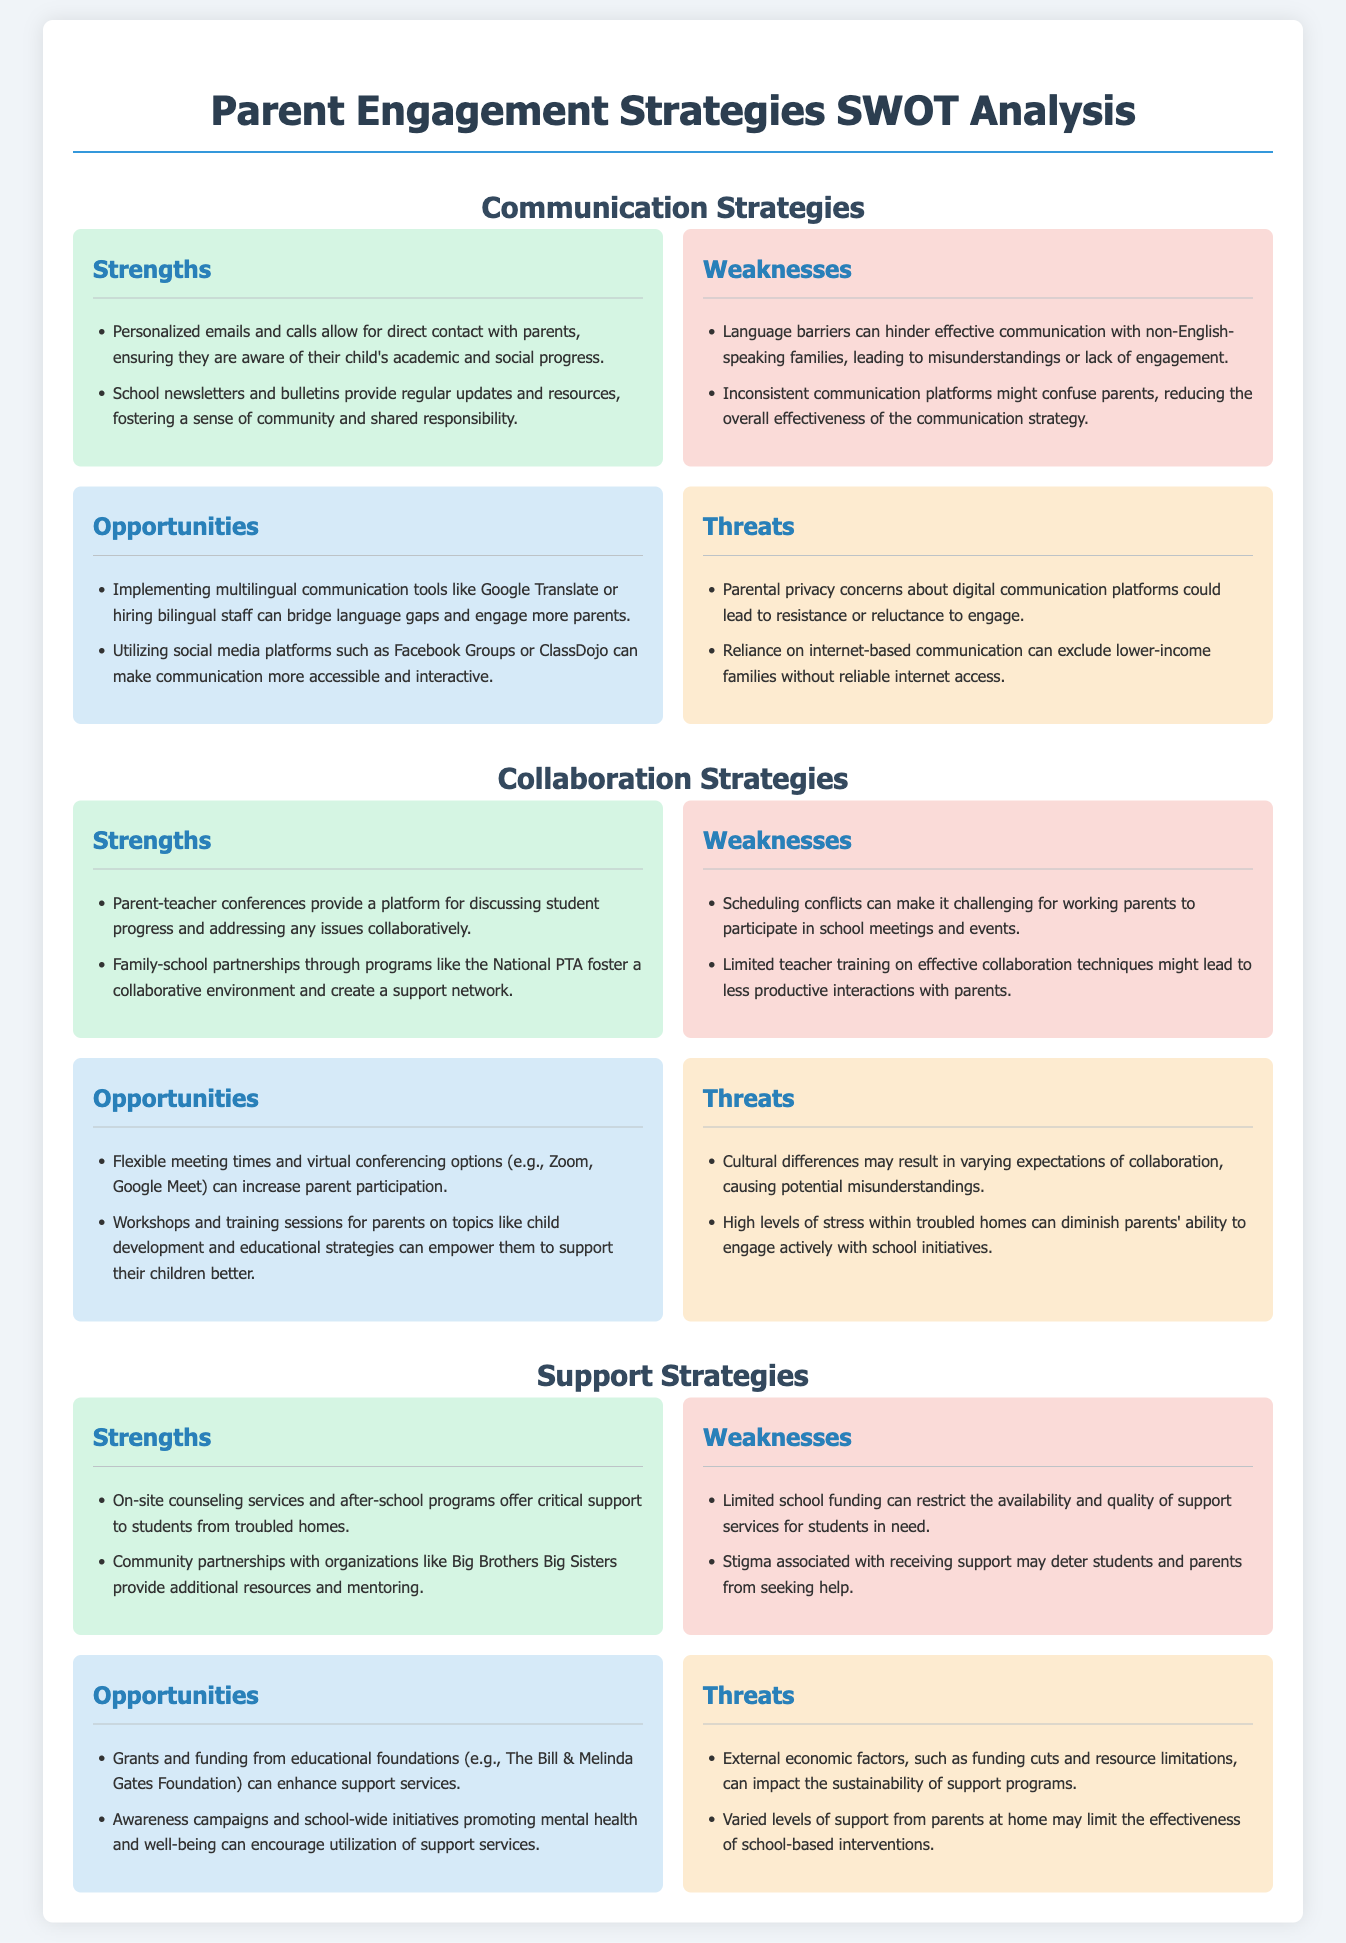What is the first strategy discussed in the document? The first strategy outlined in the document is Communication Strategies.
Answer: Communication Strategies How many weaknesses are listed under Collaboration Strategies? There are two weaknesses mentioned under Collaboration Strategies.
Answer: 2 What type of opportunities includes using social media? The opportunity to utilize social media platforms falls under Communication Strategies.
Answer: Communication Strategies What partnerships are mentioned as a strength in Support Strategies? Community partnerships with organizations like Big Brothers Big Sisters are mentioned as a strength.
Answer: Big Brothers Big Sisters What is a major threat to support programs mentioned in the document? External economic factors, such as funding cuts, are identified as a major threat.
Answer: Funding cuts How many strengths are listed under Support Strategies? There are two strengths identified under Support Strategies.
Answer: 2 What is a potential weakness in Communication Strategies related to language? Language barriers can hinder effective communication with non-English-speaking families.
Answer: Language barriers What type of campaign could encourage utilization of support services? Awareness campaigns promoting mental health and well-being could encourage utilization.
Answer: Awareness campaigns 